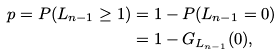Convert formula to latex. <formula><loc_0><loc_0><loc_500><loc_500>p = P ( L _ { n - 1 } \geq 1 ) & = 1 - P ( L _ { n - 1 } = 0 ) \\ & = 1 - G _ { L _ { n - 1 } } ( 0 ) ,</formula> 